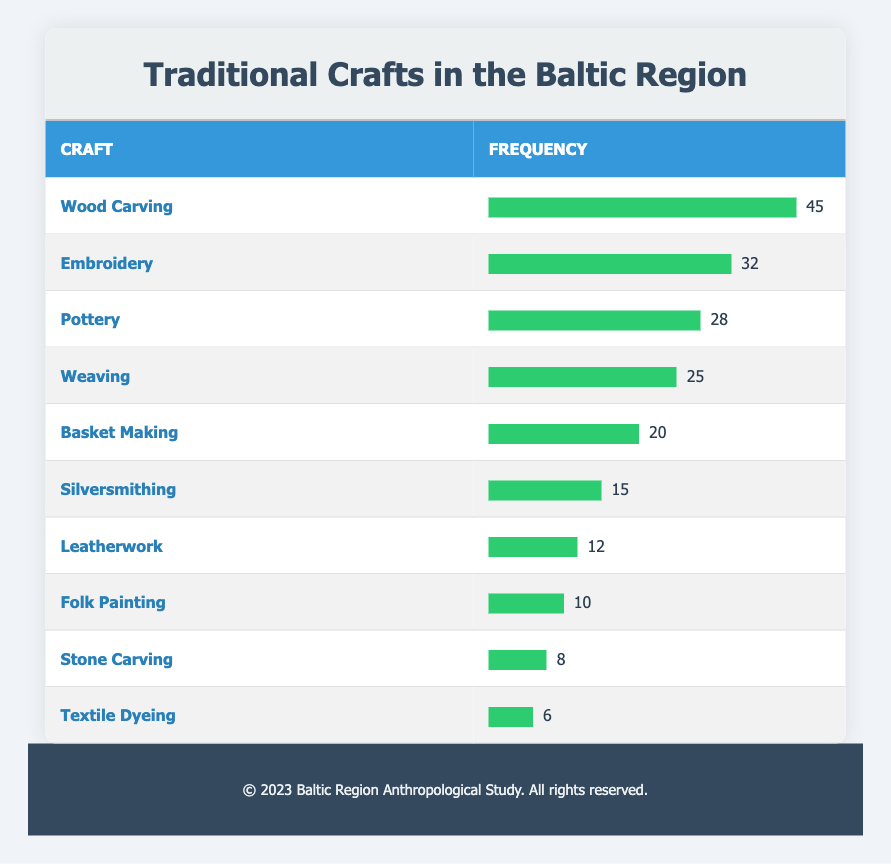What is the most frequently practiced traditional craft in the Baltic region? The table shows that "Wood Carving" has a frequency of 45, which is the highest among all crafts listed. Thus, it is the most frequently practiced traditional craft.
Answer: Wood Carving How many artisans practice Embroidery? The table indicates that the frequency for "Embroidery" is 32, meaning that 32 artisans practice this craft.
Answer: 32 What is the total frequency of Pottery and Weaving combined? By looking at the frequencies, "Pottery" has 28 and "Weaving" has 25. Adding these together (28 + 25) gives a total of 53.
Answer: 53 Is Silversmithing more frequently practiced than Leatherwork? The frequency for "Silversmithing" is 15 and for "Leatherwork" is 12. Since 15 is greater than 12, the statement is true.
Answer: Yes What percentage of artisans practice Basket Making compared to Wood Carving? The frequency for "Basket Making" is 20 and for "Wood Carving" is 45. The percentage is calculated by (20/45) * 100 = 44.44%.
Answer: 44.44% What is the cumulative frequency of the top three traditional crafts? The top three crafts are "Wood Carving" (45), "Embroidery" (32), and "Pottery" (28). Summing these (45 + 32 + 28) gives a total of 105.
Answer: 105 How many traditional crafts are practiced by fewer than 15 artisans? The table shows that "Silversmithing" (15), "Leatherwork" (12), "Folk Painting" (10), "Stone Carving" (8), and "Textile Dyeing" (6) are fewer than 15, totaling 4 crafts.
Answer: 4 What is the difference in frequency between the highest and lowest traditional craft? The highest frequency is "Wood Carving" with 45 artisans, and the lowest is "Textile Dyeing" with 6 artisans. The difference is 45 - 6 = 39.
Answer: 39 Which craft has a frequency closest to the mean frequency of all crafts? The mean frequency is calculated by taking the total frequency of all crafts (which is 45 + 32 + 28 + 25 + 20 + 15 + 12 + 10 + 8 + 6 = 301) and dividing it by the number of crafts (10). This gives a mean of 30.1. The closest frequency is "Embroidery" with 32, which is just above the mean.
Answer: Embroidery 